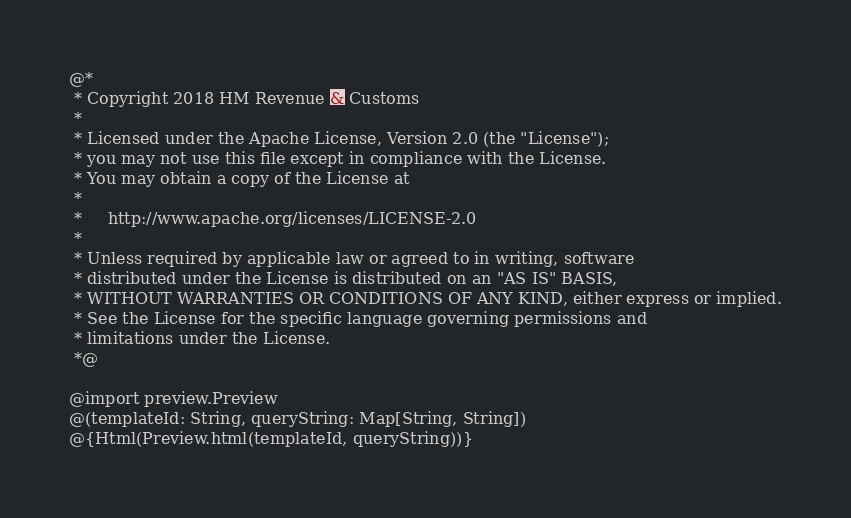<code> <loc_0><loc_0><loc_500><loc_500><_HTML_>@*
 * Copyright 2018 HM Revenue & Customs
 *
 * Licensed under the Apache License, Version 2.0 (the "License");
 * you may not use this file except in compliance with the License.
 * You may obtain a copy of the License at
 *
 *     http://www.apache.org/licenses/LICENSE-2.0
 *
 * Unless required by applicable law or agreed to in writing, software
 * distributed under the License is distributed on an "AS IS" BASIS,
 * WITHOUT WARRANTIES OR CONDITIONS OF ANY KIND, either express or implied.
 * See the License for the specific language governing permissions and
 * limitations under the License.
 *@

@import preview.Preview
@(templateId: String, queryString: Map[String, String])
@{Html(Preview.html(templateId, queryString))}</code> 